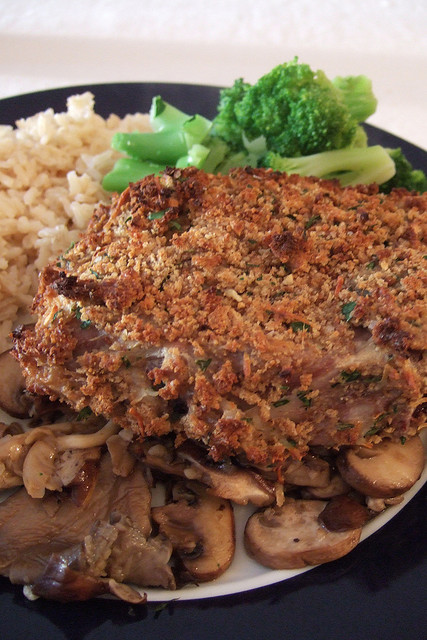<image>What kind of noodles are in the dish? The dish does not contain noodles. It possibly contains rice or pasta. What type of seeds are on the meal? There are no seeds on the meal. However, there could be sesame seeds. What kind of sea creature is this from? I don't know what kind of sea creature this is from. It could be from a fish or a squid. What type of seeds are on the meal? There are no seeds on the meal. What kind of noodles are in the dish? I don't know what kind of noodles are in the dish. It can be 'elbows', 'rice', 'brown', 'pasta' or 'none'. What kind of sea creature is this from? I am not sure what kind of sea creature this is from. It can be fish, tuna, or squid. 